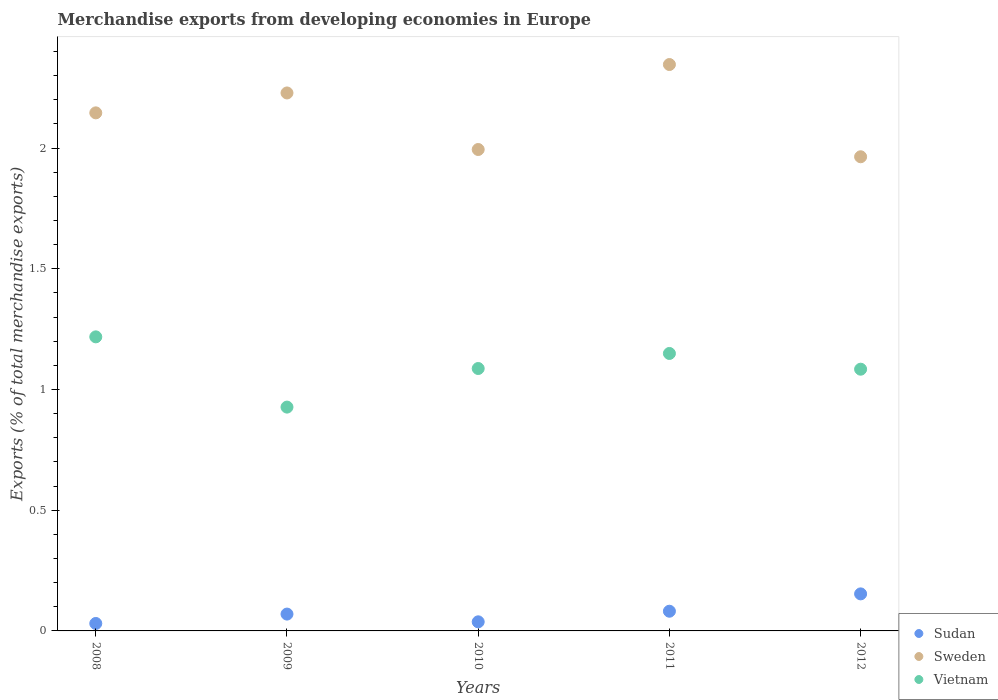Is the number of dotlines equal to the number of legend labels?
Provide a succinct answer. Yes. What is the percentage of total merchandise exports in Sweden in 2009?
Keep it short and to the point. 2.23. Across all years, what is the maximum percentage of total merchandise exports in Sweden?
Provide a short and direct response. 2.35. Across all years, what is the minimum percentage of total merchandise exports in Vietnam?
Provide a short and direct response. 0.93. What is the total percentage of total merchandise exports in Vietnam in the graph?
Your response must be concise. 5.47. What is the difference between the percentage of total merchandise exports in Sweden in 2010 and that in 2012?
Provide a succinct answer. 0.03. What is the difference between the percentage of total merchandise exports in Vietnam in 2011 and the percentage of total merchandise exports in Sudan in 2012?
Make the answer very short. 1. What is the average percentage of total merchandise exports in Sweden per year?
Ensure brevity in your answer.  2.14. In the year 2011, what is the difference between the percentage of total merchandise exports in Sudan and percentage of total merchandise exports in Vietnam?
Give a very brief answer. -1.07. What is the ratio of the percentage of total merchandise exports in Vietnam in 2009 to that in 2011?
Keep it short and to the point. 0.81. Is the difference between the percentage of total merchandise exports in Sudan in 2009 and 2010 greater than the difference between the percentage of total merchandise exports in Vietnam in 2009 and 2010?
Give a very brief answer. Yes. What is the difference between the highest and the second highest percentage of total merchandise exports in Vietnam?
Give a very brief answer. 0.07. What is the difference between the highest and the lowest percentage of total merchandise exports in Sudan?
Offer a very short reply. 0.12. Is the sum of the percentage of total merchandise exports in Sudan in 2009 and 2011 greater than the maximum percentage of total merchandise exports in Sweden across all years?
Offer a terse response. No. Does the percentage of total merchandise exports in Sweden monotonically increase over the years?
Your response must be concise. No. How many dotlines are there?
Provide a succinct answer. 3. How many years are there in the graph?
Offer a terse response. 5. Are the values on the major ticks of Y-axis written in scientific E-notation?
Offer a terse response. No. Does the graph contain any zero values?
Make the answer very short. No. Where does the legend appear in the graph?
Offer a terse response. Bottom right. How many legend labels are there?
Your response must be concise. 3. What is the title of the graph?
Your answer should be very brief. Merchandise exports from developing economies in Europe. Does "Angola" appear as one of the legend labels in the graph?
Keep it short and to the point. No. What is the label or title of the X-axis?
Provide a short and direct response. Years. What is the label or title of the Y-axis?
Your answer should be compact. Exports (% of total merchandise exports). What is the Exports (% of total merchandise exports) of Sudan in 2008?
Offer a very short reply. 0.03. What is the Exports (% of total merchandise exports) of Sweden in 2008?
Give a very brief answer. 2.15. What is the Exports (% of total merchandise exports) of Vietnam in 2008?
Give a very brief answer. 1.22. What is the Exports (% of total merchandise exports) of Sudan in 2009?
Provide a short and direct response. 0.07. What is the Exports (% of total merchandise exports) of Sweden in 2009?
Your answer should be very brief. 2.23. What is the Exports (% of total merchandise exports) of Vietnam in 2009?
Ensure brevity in your answer.  0.93. What is the Exports (% of total merchandise exports) in Sudan in 2010?
Provide a succinct answer. 0.04. What is the Exports (% of total merchandise exports) in Sweden in 2010?
Provide a short and direct response. 1.99. What is the Exports (% of total merchandise exports) of Vietnam in 2010?
Keep it short and to the point. 1.09. What is the Exports (% of total merchandise exports) in Sudan in 2011?
Your answer should be very brief. 0.08. What is the Exports (% of total merchandise exports) of Sweden in 2011?
Your response must be concise. 2.35. What is the Exports (% of total merchandise exports) of Vietnam in 2011?
Your answer should be compact. 1.15. What is the Exports (% of total merchandise exports) of Sudan in 2012?
Provide a short and direct response. 0.15. What is the Exports (% of total merchandise exports) in Sweden in 2012?
Provide a succinct answer. 1.96. What is the Exports (% of total merchandise exports) of Vietnam in 2012?
Provide a short and direct response. 1.08. Across all years, what is the maximum Exports (% of total merchandise exports) in Sudan?
Offer a very short reply. 0.15. Across all years, what is the maximum Exports (% of total merchandise exports) of Sweden?
Ensure brevity in your answer.  2.35. Across all years, what is the maximum Exports (% of total merchandise exports) in Vietnam?
Ensure brevity in your answer.  1.22. Across all years, what is the minimum Exports (% of total merchandise exports) in Sudan?
Your answer should be very brief. 0.03. Across all years, what is the minimum Exports (% of total merchandise exports) of Sweden?
Your answer should be compact. 1.96. Across all years, what is the minimum Exports (% of total merchandise exports) of Vietnam?
Provide a short and direct response. 0.93. What is the total Exports (% of total merchandise exports) of Sudan in the graph?
Give a very brief answer. 0.37. What is the total Exports (% of total merchandise exports) of Sweden in the graph?
Your response must be concise. 10.68. What is the total Exports (% of total merchandise exports) of Vietnam in the graph?
Provide a succinct answer. 5.47. What is the difference between the Exports (% of total merchandise exports) of Sudan in 2008 and that in 2009?
Offer a terse response. -0.04. What is the difference between the Exports (% of total merchandise exports) in Sweden in 2008 and that in 2009?
Your response must be concise. -0.08. What is the difference between the Exports (% of total merchandise exports) in Vietnam in 2008 and that in 2009?
Give a very brief answer. 0.29. What is the difference between the Exports (% of total merchandise exports) of Sudan in 2008 and that in 2010?
Ensure brevity in your answer.  -0.01. What is the difference between the Exports (% of total merchandise exports) of Sweden in 2008 and that in 2010?
Your answer should be compact. 0.15. What is the difference between the Exports (% of total merchandise exports) in Vietnam in 2008 and that in 2010?
Ensure brevity in your answer.  0.13. What is the difference between the Exports (% of total merchandise exports) in Sudan in 2008 and that in 2011?
Offer a terse response. -0.05. What is the difference between the Exports (% of total merchandise exports) in Sweden in 2008 and that in 2011?
Your response must be concise. -0.2. What is the difference between the Exports (% of total merchandise exports) of Vietnam in 2008 and that in 2011?
Keep it short and to the point. 0.07. What is the difference between the Exports (% of total merchandise exports) of Sudan in 2008 and that in 2012?
Provide a succinct answer. -0.12. What is the difference between the Exports (% of total merchandise exports) of Sweden in 2008 and that in 2012?
Ensure brevity in your answer.  0.18. What is the difference between the Exports (% of total merchandise exports) in Vietnam in 2008 and that in 2012?
Make the answer very short. 0.13. What is the difference between the Exports (% of total merchandise exports) of Sudan in 2009 and that in 2010?
Keep it short and to the point. 0.03. What is the difference between the Exports (% of total merchandise exports) of Sweden in 2009 and that in 2010?
Provide a short and direct response. 0.23. What is the difference between the Exports (% of total merchandise exports) in Vietnam in 2009 and that in 2010?
Your answer should be very brief. -0.16. What is the difference between the Exports (% of total merchandise exports) of Sudan in 2009 and that in 2011?
Provide a succinct answer. -0.01. What is the difference between the Exports (% of total merchandise exports) of Sweden in 2009 and that in 2011?
Give a very brief answer. -0.12. What is the difference between the Exports (% of total merchandise exports) of Vietnam in 2009 and that in 2011?
Offer a terse response. -0.22. What is the difference between the Exports (% of total merchandise exports) in Sudan in 2009 and that in 2012?
Provide a short and direct response. -0.08. What is the difference between the Exports (% of total merchandise exports) in Sweden in 2009 and that in 2012?
Provide a short and direct response. 0.26. What is the difference between the Exports (% of total merchandise exports) of Vietnam in 2009 and that in 2012?
Your answer should be very brief. -0.16. What is the difference between the Exports (% of total merchandise exports) of Sudan in 2010 and that in 2011?
Give a very brief answer. -0.04. What is the difference between the Exports (% of total merchandise exports) in Sweden in 2010 and that in 2011?
Make the answer very short. -0.35. What is the difference between the Exports (% of total merchandise exports) in Vietnam in 2010 and that in 2011?
Ensure brevity in your answer.  -0.06. What is the difference between the Exports (% of total merchandise exports) of Sudan in 2010 and that in 2012?
Your response must be concise. -0.12. What is the difference between the Exports (% of total merchandise exports) in Sweden in 2010 and that in 2012?
Provide a succinct answer. 0.03. What is the difference between the Exports (% of total merchandise exports) in Vietnam in 2010 and that in 2012?
Offer a terse response. 0. What is the difference between the Exports (% of total merchandise exports) in Sudan in 2011 and that in 2012?
Offer a terse response. -0.07. What is the difference between the Exports (% of total merchandise exports) of Sweden in 2011 and that in 2012?
Make the answer very short. 0.38. What is the difference between the Exports (% of total merchandise exports) in Vietnam in 2011 and that in 2012?
Ensure brevity in your answer.  0.07. What is the difference between the Exports (% of total merchandise exports) in Sudan in 2008 and the Exports (% of total merchandise exports) in Sweden in 2009?
Your answer should be compact. -2.2. What is the difference between the Exports (% of total merchandise exports) of Sudan in 2008 and the Exports (% of total merchandise exports) of Vietnam in 2009?
Give a very brief answer. -0.9. What is the difference between the Exports (% of total merchandise exports) of Sweden in 2008 and the Exports (% of total merchandise exports) of Vietnam in 2009?
Your response must be concise. 1.22. What is the difference between the Exports (% of total merchandise exports) of Sudan in 2008 and the Exports (% of total merchandise exports) of Sweden in 2010?
Offer a very short reply. -1.96. What is the difference between the Exports (% of total merchandise exports) in Sudan in 2008 and the Exports (% of total merchandise exports) in Vietnam in 2010?
Make the answer very short. -1.06. What is the difference between the Exports (% of total merchandise exports) of Sweden in 2008 and the Exports (% of total merchandise exports) of Vietnam in 2010?
Your response must be concise. 1.06. What is the difference between the Exports (% of total merchandise exports) of Sudan in 2008 and the Exports (% of total merchandise exports) of Sweden in 2011?
Provide a succinct answer. -2.32. What is the difference between the Exports (% of total merchandise exports) in Sudan in 2008 and the Exports (% of total merchandise exports) in Vietnam in 2011?
Ensure brevity in your answer.  -1.12. What is the difference between the Exports (% of total merchandise exports) of Sudan in 2008 and the Exports (% of total merchandise exports) of Sweden in 2012?
Provide a succinct answer. -1.93. What is the difference between the Exports (% of total merchandise exports) in Sudan in 2008 and the Exports (% of total merchandise exports) in Vietnam in 2012?
Make the answer very short. -1.05. What is the difference between the Exports (% of total merchandise exports) in Sweden in 2008 and the Exports (% of total merchandise exports) in Vietnam in 2012?
Offer a very short reply. 1.06. What is the difference between the Exports (% of total merchandise exports) of Sudan in 2009 and the Exports (% of total merchandise exports) of Sweden in 2010?
Provide a succinct answer. -1.92. What is the difference between the Exports (% of total merchandise exports) of Sudan in 2009 and the Exports (% of total merchandise exports) of Vietnam in 2010?
Make the answer very short. -1.02. What is the difference between the Exports (% of total merchandise exports) in Sweden in 2009 and the Exports (% of total merchandise exports) in Vietnam in 2010?
Provide a succinct answer. 1.14. What is the difference between the Exports (% of total merchandise exports) in Sudan in 2009 and the Exports (% of total merchandise exports) in Sweden in 2011?
Your response must be concise. -2.28. What is the difference between the Exports (% of total merchandise exports) of Sudan in 2009 and the Exports (% of total merchandise exports) of Vietnam in 2011?
Provide a succinct answer. -1.08. What is the difference between the Exports (% of total merchandise exports) of Sweden in 2009 and the Exports (% of total merchandise exports) of Vietnam in 2011?
Offer a very short reply. 1.08. What is the difference between the Exports (% of total merchandise exports) in Sudan in 2009 and the Exports (% of total merchandise exports) in Sweden in 2012?
Your response must be concise. -1.89. What is the difference between the Exports (% of total merchandise exports) of Sudan in 2009 and the Exports (% of total merchandise exports) of Vietnam in 2012?
Provide a succinct answer. -1.01. What is the difference between the Exports (% of total merchandise exports) in Sweden in 2009 and the Exports (% of total merchandise exports) in Vietnam in 2012?
Offer a very short reply. 1.14. What is the difference between the Exports (% of total merchandise exports) in Sudan in 2010 and the Exports (% of total merchandise exports) in Sweden in 2011?
Keep it short and to the point. -2.31. What is the difference between the Exports (% of total merchandise exports) of Sudan in 2010 and the Exports (% of total merchandise exports) of Vietnam in 2011?
Keep it short and to the point. -1.11. What is the difference between the Exports (% of total merchandise exports) of Sweden in 2010 and the Exports (% of total merchandise exports) of Vietnam in 2011?
Your response must be concise. 0.84. What is the difference between the Exports (% of total merchandise exports) in Sudan in 2010 and the Exports (% of total merchandise exports) in Sweden in 2012?
Make the answer very short. -1.93. What is the difference between the Exports (% of total merchandise exports) of Sudan in 2010 and the Exports (% of total merchandise exports) of Vietnam in 2012?
Make the answer very short. -1.05. What is the difference between the Exports (% of total merchandise exports) in Sweden in 2010 and the Exports (% of total merchandise exports) in Vietnam in 2012?
Keep it short and to the point. 0.91. What is the difference between the Exports (% of total merchandise exports) in Sudan in 2011 and the Exports (% of total merchandise exports) in Sweden in 2012?
Make the answer very short. -1.88. What is the difference between the Exports (% of total merchandise exports) of Sudan in 2011 and the Exports (% of total merchandise exports) of Vietnam in 2012?
Ensure brevity in your answer.  -1. What is the difference between the Exports (% of total merchandise exports) in Sweden in 2011 and the Exports (% of total merchandise exports) in Vietnam in 2012?
Give a very brief answer. 1.26. What is the average Exports (% of total merchandise exports) in Sudan per year?
Provide a succinct answer. 0.07. What is the average Exports (% of total merchandise exports) in Sweden per year?
Provide a succinct answer. 2.14. What is the average Exports (% of total merchandise exports) of Vietnam per year?
Your response must be concise. 1.09. In the year 2008, what is the difference between the Exports (% of total merchandise exports) in Sudan and Exports (% of total merchandise exports) in Sweden?
Your response must be concise. -2.12. In the year 2008, what is the difference between the Exports (% of total merchandise exports) in Sudan and Exports (% of total merchandise exports) in Vietnam?
Make the answer very short. -1.19. In the year 2008, what is the difference between the Exports (% of total merchandise exports) in Sweden and Exports (% of total merchandise exports) in Vietnam?
Make the answer very short. 0.93. In the year 2009, what is the difference between the Exports (% of total merchandise exports) of Sudan and Exports (% of total merchandise exports) of Sweden?
Offer a very short reply. -2.16. In the year 2009, what is the difference between the Exports (% of total merchandise exports) of Sudan and Exports (% of total merchandise exports) of Vietnam?
Offer a terse response. -0.86. In the year 2009, what is the difference between the Exports (% of total merchandise exports) of Sweden and Exports (% of total merchandise exports) of Vietnam?
Offer a very short reply. 1.3. In the year 2010, what is the difference between the Exports (% of total merchandise exports) of Sudan and Exports (% of total merchandise exports) of Sweden?
Give a very brief answer. -1.96. In the year 2010, what is the difference between the Exports (% of total merchandise exports) of Sudan and Exports (% of total merchandise exports) of Vietnam?
Give a very brief answer. -1.05. In the year 2010, what is the difference between the Exports (% of total merchandise exports) of Sweden and Exports (% of total merchandise exports) of Vietnam?
Keep it short and to the point. 0.91. In the year 2011, what is the difference between the Exports (% of total merchandise exports) in Sudan and Exports (% of total merchandise exports) in Sweden?
Provide a succinct answer. -2.26. In the year 2011, what is the difference between the Exports (% of total merchandise exports) of Sudan and Exports (% of total merchandise exports) of Vietnam?
Make the answer very short. -1.07. In the year 2011, what is the difference between the Exports (% of total merchandise exports) in Sweden and Exports (% of total merchandise exports) in Vietnam?
Provide a succinct answer. 1.2. In the year 2012, what is the difference between the Exports (% of total merchandise exports) of Sudan and Exports (% of total merchandise exports) of Sweden?
Provide a succinct answer. -1.81. In the year 2012, what is the difference between the Exports (% of total merchandise exports) of Sudan and Exports (% of total merchandise exports) of Vietnam?
Make the answer very short. -0.93. What is the ratio of the Exports (% of total merchandise exports) of Sudan in 2008 to that in 2009?
Your response must be concise. 0.44. What is the ratio of the Exports (% of total merchandise exports) of Vietnam in 2008 to that in 2009?
Make the answer very short. 1.31. What is the ratio of the Exports (% of total merchandise exports) of Sudan in 2008 to that in 2010?
Offer a terse response. 0.82. What is the ratio of the Exports (% of total merchandise exports) of Sweden in 2008 to that in 2010?
Your answer should be very brief. 1.08. What is the ratio of the Exports (% of total merchandise exports) in Vietnam in 2008 to that in 2010?
Give a very brief answer. 1.12. What is the ratio of the Exports (% of total merchandise exports) of Sudan in 2008 to that in 2011?
Provide a succinct answer. 0.38. What is the ratio of the Exports (% of total merchandise exports) in Sweden in 2008 to that in 2011?
Provide a succinct answer. 0.91. What is the ratio of the Exports (% of total merchandise exports) in Vietnam in 2008 to that in 2011?
Offer a very short reply. 1.06. What is the ratio of the Exports (% of total merchandise exports) of Sudan in 2008 to that in 2012?
Your answer should be compact. 0.2. What is the ratio of the Exports (% of total merchandise exports) of Sweden in 2008 to that in 2012?
Ensure brevity in your answer.  1.09. What is the ratio of the Exports (% of total merchandise exports) in Vietnam in 2008 to that in 2012?
Keep it short and to the point. 1.12. What is the ratio of the Exports (% of total merchandise exports) of Sudan in 2009 to that in 2010?
Your response must be concise. 1.85. What is the ratio of the Exports (% of total merchandise exports) in Sweden in 2009 to that in 2010?
Keep it short and to the point. 1.12. What is the ratio of the Exports (% of total merchandise exports) in Vietnam in 2009 to that in 2010?
Your answer should be very brief. 0.85. What is the ratio of the Exports (% of total merchandise exports) in Sudan in 2009 to that in 2011?
Your answer should be compact. 0.85. What is the ratio of the Exports (% of total merchandise exports) of Sweden in 2009 to that in 2011?
Give a very brief answer. 0.95. What is the ratio of the Exports (% of total merchandise exports) of Vietnam in 2009 to that in 2011?
Offer a very short reply. 0.81. What is the ratio of the Exports (% of total merchandise exports) in Sudan in 2009 to that in 2012?
Your response must be concise. 0.45. What is the ratio of the Exports (% of total merchandise exports) of Sweden in 2009 to that in 2012?
Your answer should be compact. 1.13. What is the ratio of the Exports (% of total merchandise exports) in Vietnam in 2009 to that in 2012?
Your response must be concise. 0.86. What is the ratio of the Exports (% of total merchandise exports) in Sudan in 2010 to that in 2011?
Provide a succinct answer. 0.46. What is the ratio of the Exports (% of total merchandise exports) of Vietnam in 2010 to that in 2011?
Ensure brevity in your answer.  0.95. What is the ratio of the Exports (% of total merchandise exports) of Sudan in 2010 to that in 2012?
Your answer should be very brief. 0.25. What is the ratio of the Exports (% of total merchandise exports) of Sweden in 2010 to that in 2012?
Provide a succinct answer. 1.02. What is the ratio of the Exports (% of total merchandise exports) of Vietnam in 2010 to that in 2012?
Offer a very short reply. 1. What is the ratio of the Exports (% of total merchandise exports) in Sudan in 2011 to that in 2012?
Ensure brevity in your answer.  0.53. What is the ratio of the Exports (% of total merchandise exports) of Sweden in 2011 to that in 2012?
Offer a very short reply. 1.19. What is the ratio of the Exports (% of total merchandise exports) in Vietnam in 2011 to that in 2012?
Make the answer very short. 1.06. What is the difference between the highest and the second highest Exports (% of total merchandise exports) in Sudan?
Make the answer very short. 0.07. What is the difference between the highest and the second highest Exports (% of total merchandise exports) in Sweden?
Offer a terse response. 0.12. What is the difference between the highest and the second highest Exports (% of total merchandise exports) in Vietnam?
Offer a very short reply. 0.07. What is the difference between the highest and the lowest Exports (% of total merchandise exports) in Sudan?
Offer a terse response. 0.12. What is the difference between the highest and the lowest Exports (% of total merchandise exports) of Sweden?
Your answer should be compact. 0.38. What is the difference between the highest and the lowest Exports (% of total merchandise exports) in Vietnam?
Offer a very short reply. 0.29. 